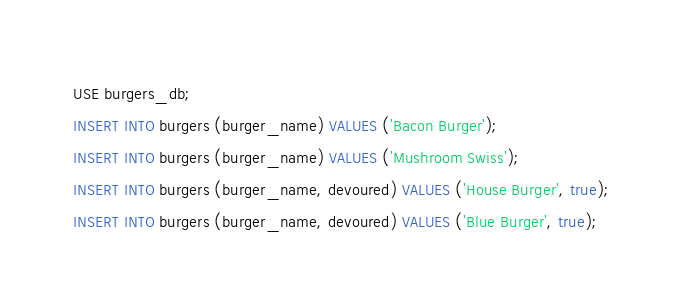<code> <loc_0><loc_0><loc_500><loc_500><_SQL_>USE burgers_db;
INSERT INTO burgers (burger_name) VALUES ('Bacon Burger');
INSERT INTO burgers (burger_name) VALUES ('Mushroom Swiss');
INSERT INTO burgers (burger_name, devoured) VALUES ('House Burger', true);
INSERT INTO burgers (burger_name, devoured) VALUES ('Blue Burger', true);</code> 